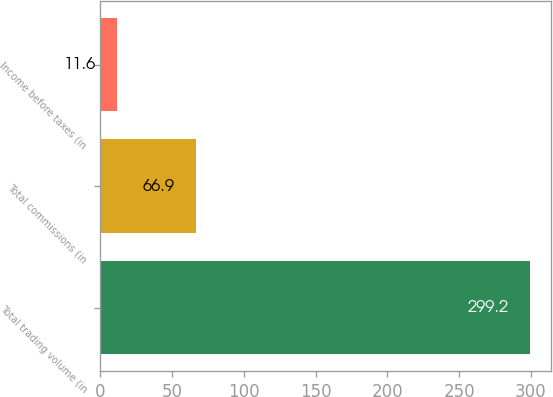Convert chart to OTSL. <chart><loc_0><loc_0><loc_500><loc_500><bar_chart><fcel>Total trading volume (in<fcel>Total commissions (in<fcel>Income before taxes (in<nl><fcel>299.2<fcel>66.9<fcel>11.6<nl></chart> 